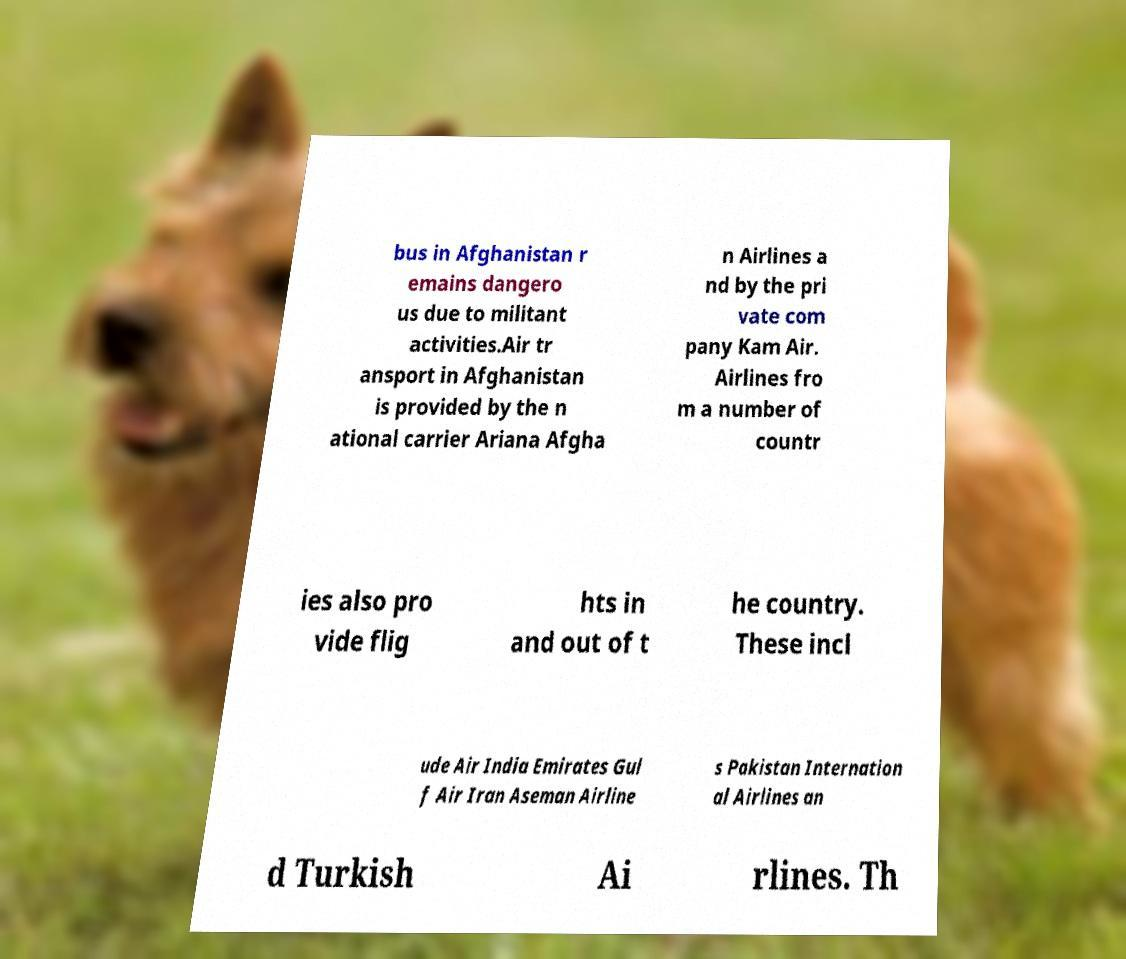Can you read and provide the text displayed in the image?This photo seems to have some interesting text. Can you extract and type it out for me? bus in Afghanistan r emains dangero us due to militant activities.Air tr ansport in Afghanistan is provided by the n ational carrier Ariana Afgha n Airlines a nd by the pri vate com pany Kam Air. Airlines fro m a number of countr ies also pro vide flig hts in and out of t he country. These incl ude Air India Emirates Gul f Air Iran Aseman Airline s Pakistan Internation al Airlines an d Turkish Ai rlines. Th 